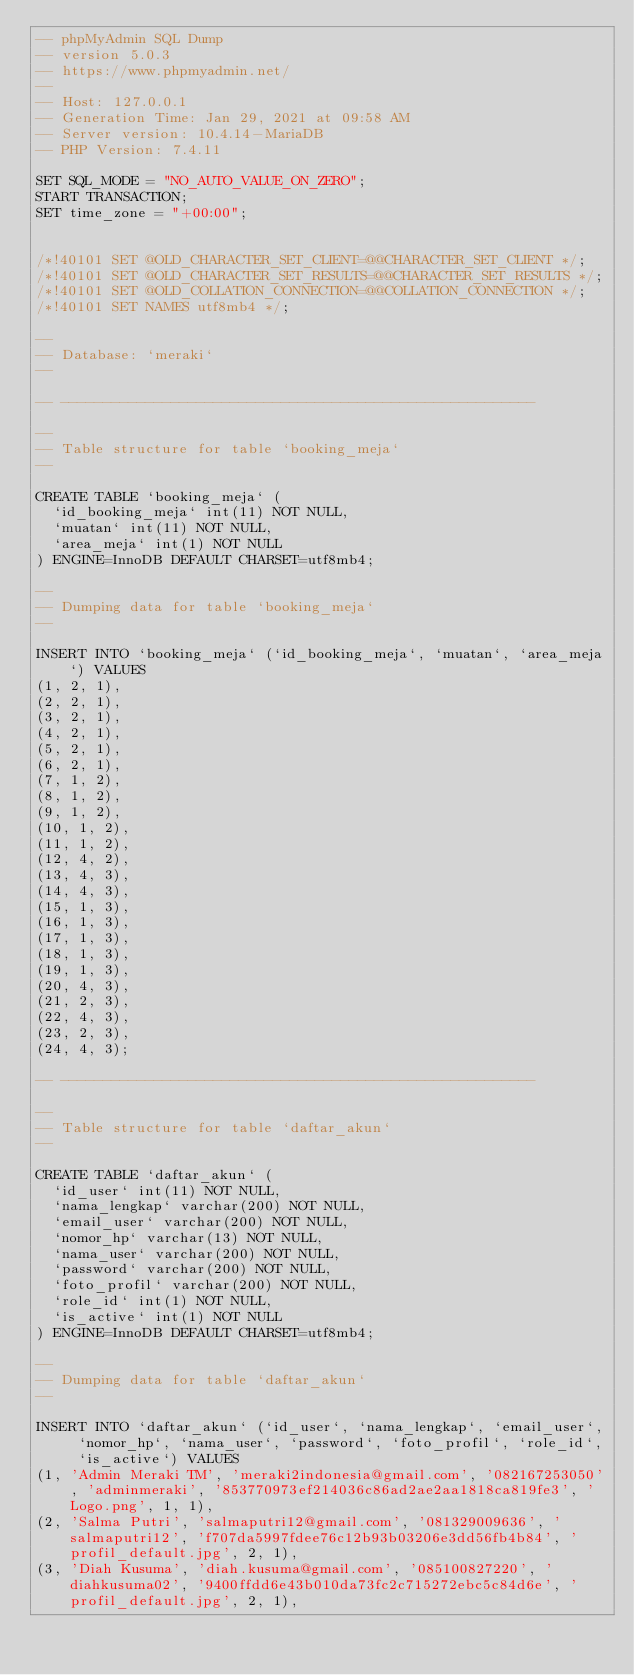Convert code to text. <code><loc_0><loc_0><loc_500><loc_500><_SQL_>-- phpMyAdmin SQL Dump
-- version 5.0.3
-- https://www.phpmyadmin.net/
--
-- Host: 127.0.0.1
-- Generation Time: Jan 29, 2021 at 09:58 AM
-- Server version: 10.4.14-MariaDB
-- PHP Version: 7.4.11

SET SQL_MODE = "NO_AUTO_VALUE_ON_ZERO";
START TRANSACTION;
SET time_zone = "+00:00";


/*!40101 SET @OLD_CHARACTER_SET_CLIENT=@@CHARACTER_SET_CLIENT */;
/*!40101 SET @OLD_CHARACTER_SET_RESULTS=@@CHARACTER_SET_RESULTS */;
/*!40101 SET @OLD_COLLATION_CONNECTION=@@COLLATION_CONNECTION */;
/*!40101 SET NAMES utf8mb4 */;

--
-- Database: `meraki`
--

-- --------------------------------------------------------

--
-- Table structure for table `booking_meja`
--

CREATE TABLE `booking_meja` (
  `id_booking_meja` int(11) NOT NULL,
  `muatan` int(11) NOT NULL,
  `area_meja` int(1) NOT NULL
) ENGINE=InnoDB DEFAULT CHARSET=utf8mb4;

--
-- Dumping data for table `booking_meja`
--

INSERT INTO `booking_meja` (`id_booking_meja`, `muatan`, `area_meja`) VALUES
(1, 2, 1),
(2, 2, 1),
(3, 2, 1),
(4, 2, 1),
(5, 2, 1),
(6, 2, 1),
(7, 1, 2),
(8, 1, 2),
(9, 1, 2),
(10, 1, 2),
(11, 1, 2),
(12, 4, 2),
(13, 4, 3),
(14, 4, 3),
(15, 1, 3),
(16, 1, 3),
(17, 1, 3),
(18, 1, 3),
(19, 1, 3),
(20, 4, 3),
(21, 2, 3),
(22, 4, 3),
(23, 2, 3),
(24, 4, 3);

-- --------------------------------------------------------

--
-- Table structure for table `daftar_akun`
--

CREATE TABLE `daftar_akun` (
  `id_user` int(11) NOT NULL,
  `nama_lengkap` varchar(200) NOT NULL,
  `email_user` varchar(200) NOT NULL,
  `nomor_hp` varchar(13) NOT NULL,
  `nama_user` varchar(200) NOT NULL,
  `password` varchar(200) NOT NULL,
  `foto_profil` varchar(200) NOT NULL,
  `role_id` int(1) NOT NULL,
  `is_active` int(1) NOT NULL
) ENGINE=InnoDB DEFAULT CHARSET=utf8mb4;

--
-- Dumping data for table `daftar_akun`
--

INSERT INTO `daftar_akun` (`id_user`, `nama_lengkap`, `email_user`, `nomor_hp`, `nama_user`, `password`, `foto_profil`, `role_id`, `is_active`) VALUES
(1, 'Admin Meraki TM', 'meraki2indonesia@gmail.com', '082167253050', 'adminmeraki', '853770973ef214036c86ad2ae2aa1818ca819fe3', 'Logo.png', 1, 1),
(2, 'Salma Putri', 'salmaputri12@gmail.com', '081329009636', 'salmaputri12', 'f707da5997fdee76c12b93b03206e3dd56fb4b84', 'profil_default.jpg', 2, 1),
(3, 'Diah Kusuma', 'diah.kusuma@gmail.com', '085100827220', 'diahkusuma02', '9400ffdd6e43b010da73fc2c715272ebc5c84d6e', 'profil_default.jpg', 2, 1),</code> 